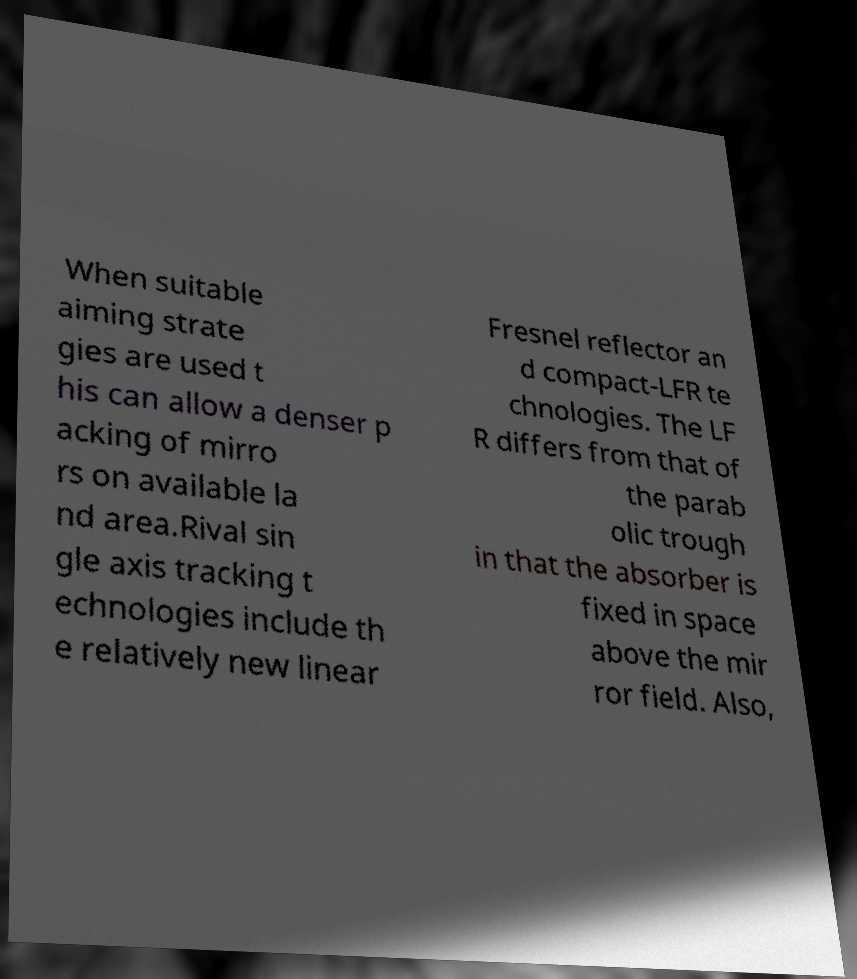Could you extract and type out the text from this image? When suitable aiming strate gies are used t his can allow a denser p acking of mirro rs on available la nd area.Rival sin gle axis tracking t echnologies include th e relatively new linear Fresnel reflector an d compact-LFR te chnologies. The LF R differs from that of the parab olic trough in that the absorber is fixed in space above the mir ror field. Also, 